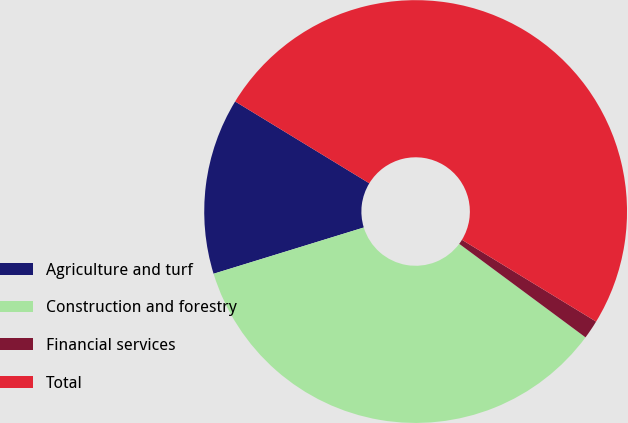Convert chart. <chart><loc_0><loc_0><loc_500><loc_500><pie_chart><fcel>Agriculture and turf<fcel>Construction and forestry<fcel>Financial services<fcel>Total<nl><fcel>13.47%<fcel>35.1%<fcel>1.43%<fcel>50.0%<nl></chart> 